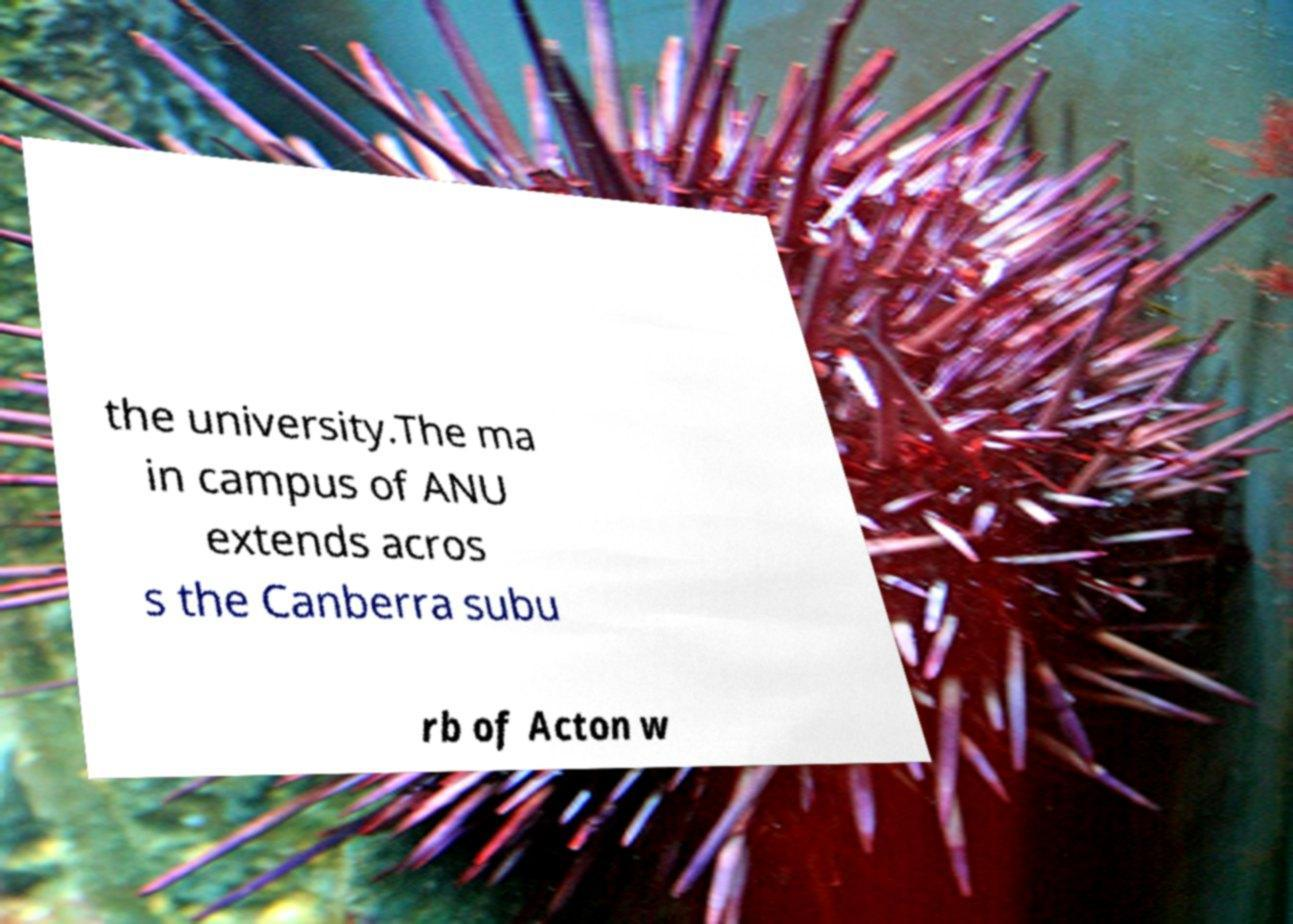Could you assist in decoding the text presented in this image and type it out clearly? the university.The ma in campus of ANU extends acros s the Canberra subu rb of Acton w 